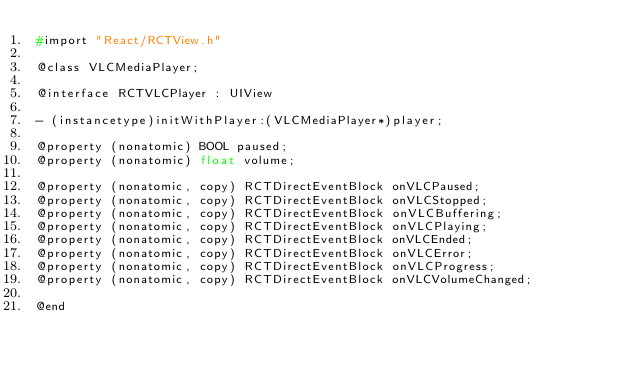<code> <loc_0><loc_0><loc_500><loc_500><_C_>#import "React/RCTView.h"

@class VLCMediaPlayer;

@interface RCTVLCPlayer : UIView

- (instancetype)initWithPlayer:(VLCMediaPlayer*)player;

@property (nonatomic) BOOL paused;
@property (nonatomic) float volume;

@property (nonatomic, copy) RCTDirectEventBlock onVLCPaused;
@property (nonatomic, copy) RCTDirectEventBlock onVLCStopped;
@property (nonatomic, copy) RCTDirectEventBlock onVLCBuffering;
@property (nonatomic, copy) RCTDirectEventBlock onVLCPlaying;
@property (nonatomic, copy) RCTDirectEventBlock onVLCEnded;
@property (nonatomic, copy) RCTDirectEventBlock onVLCError;
@property (nonatomic, copy) RCTDirectEventBlock onVLCProgress;
@property (nonatomic, copy) RCTDirectEventBlock onVLCVolumeChanged;

@end
</code> 